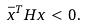<formula> <loc_0><loc_0><loc_500><loc_500>\bar { x } ^ { T } H x < 0 .</formula> 